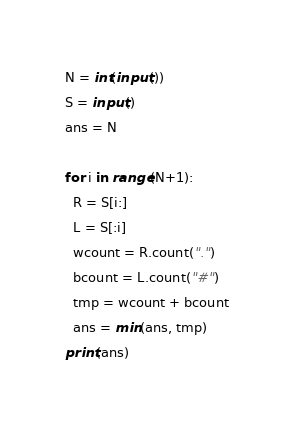<code> <loc_0><loc_0><loc_500><loc_500><_Python_>N = int(input())
S = input()
ans = N

for i in range(N+1):
  R = S[i:]
  L = S[:i]
  wcount = R.count(".")
  bcount = L.count("#")
  tmp = wcount + bcount
  ans = min(ans, tmp)
print(ans)</code> 